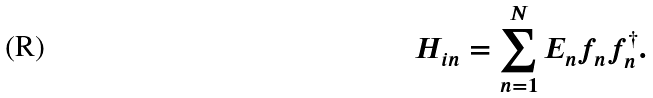<formula> <loc_0><loc_0><loc_500><loc_500>H _ { i n } = \sum _ { n = 1 } ^ { N } E _ { n } f _ { n } f _ { n } ^ { \dagger } .</formula> 